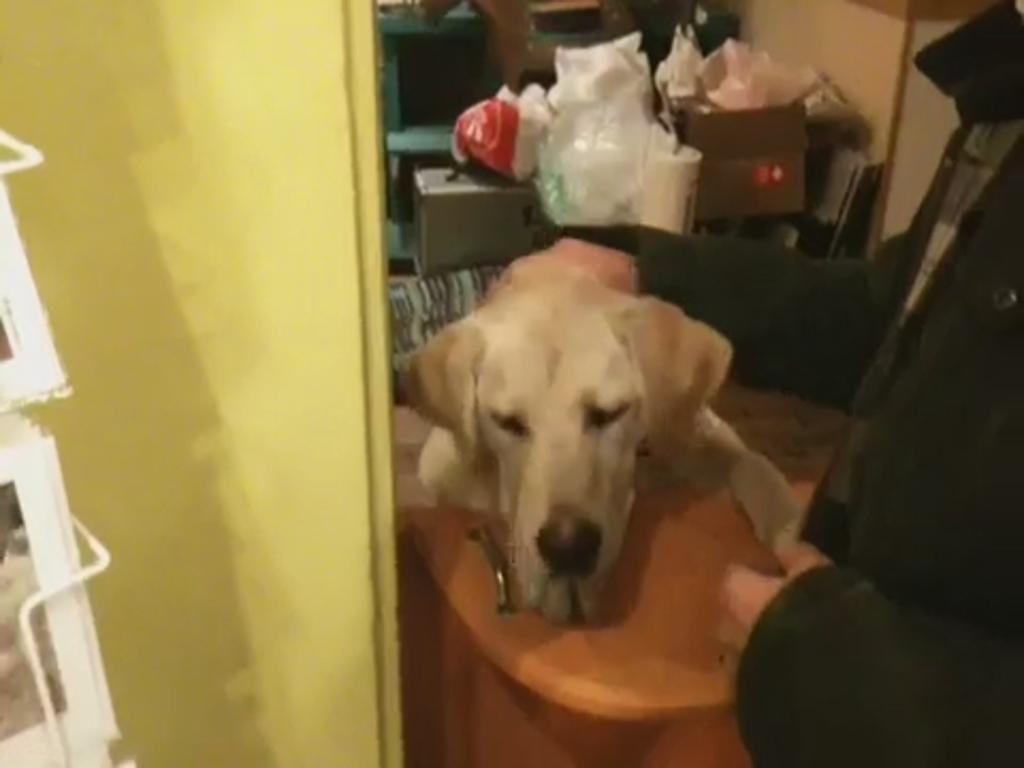Who or what is the main subject in the image? There is a person in the image. What is the person doing in the image? The person is holding a dog. What else can be seen in the image besides the person and the dog? There are cardboard boxes and other objects present in the image. How does the wind affect the person's smile in the image? There is no mention of wind or a smile in the image, so we cannot determine how the wind might affect the person's smile. 